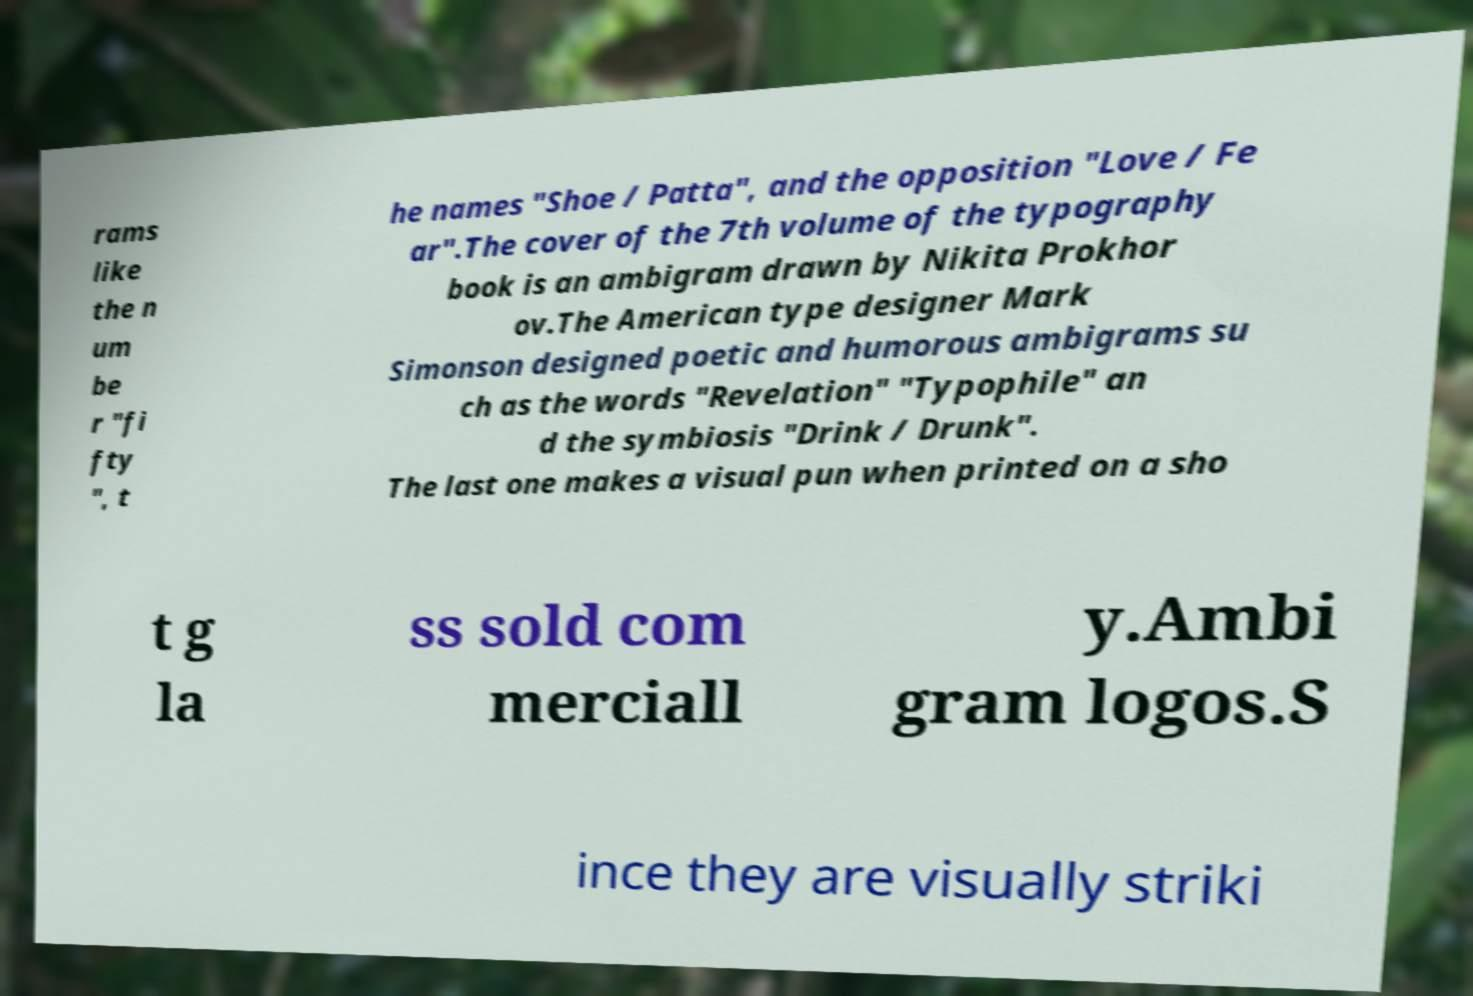For documentation purposes, I need the text within this image transcribed. Could you provide that? rams like the n um be r "fi fty ", t he names "Shoe / Patta", and the opposition "Love / Fe ar".The cover of the 7th volume of the typography book is an ambigram drawn by Nikita Prokhor ov.The American type designer Mark Simonson designed poetic and humorous ambigrams su ch as the words "Revelation" "Typophile" an d the symbiosis "Drink / Drunk". The last one makes a visual pun when printed on a sho t g la ss sold com merciall y.Ambi gram logos.S ince they are visually striki 